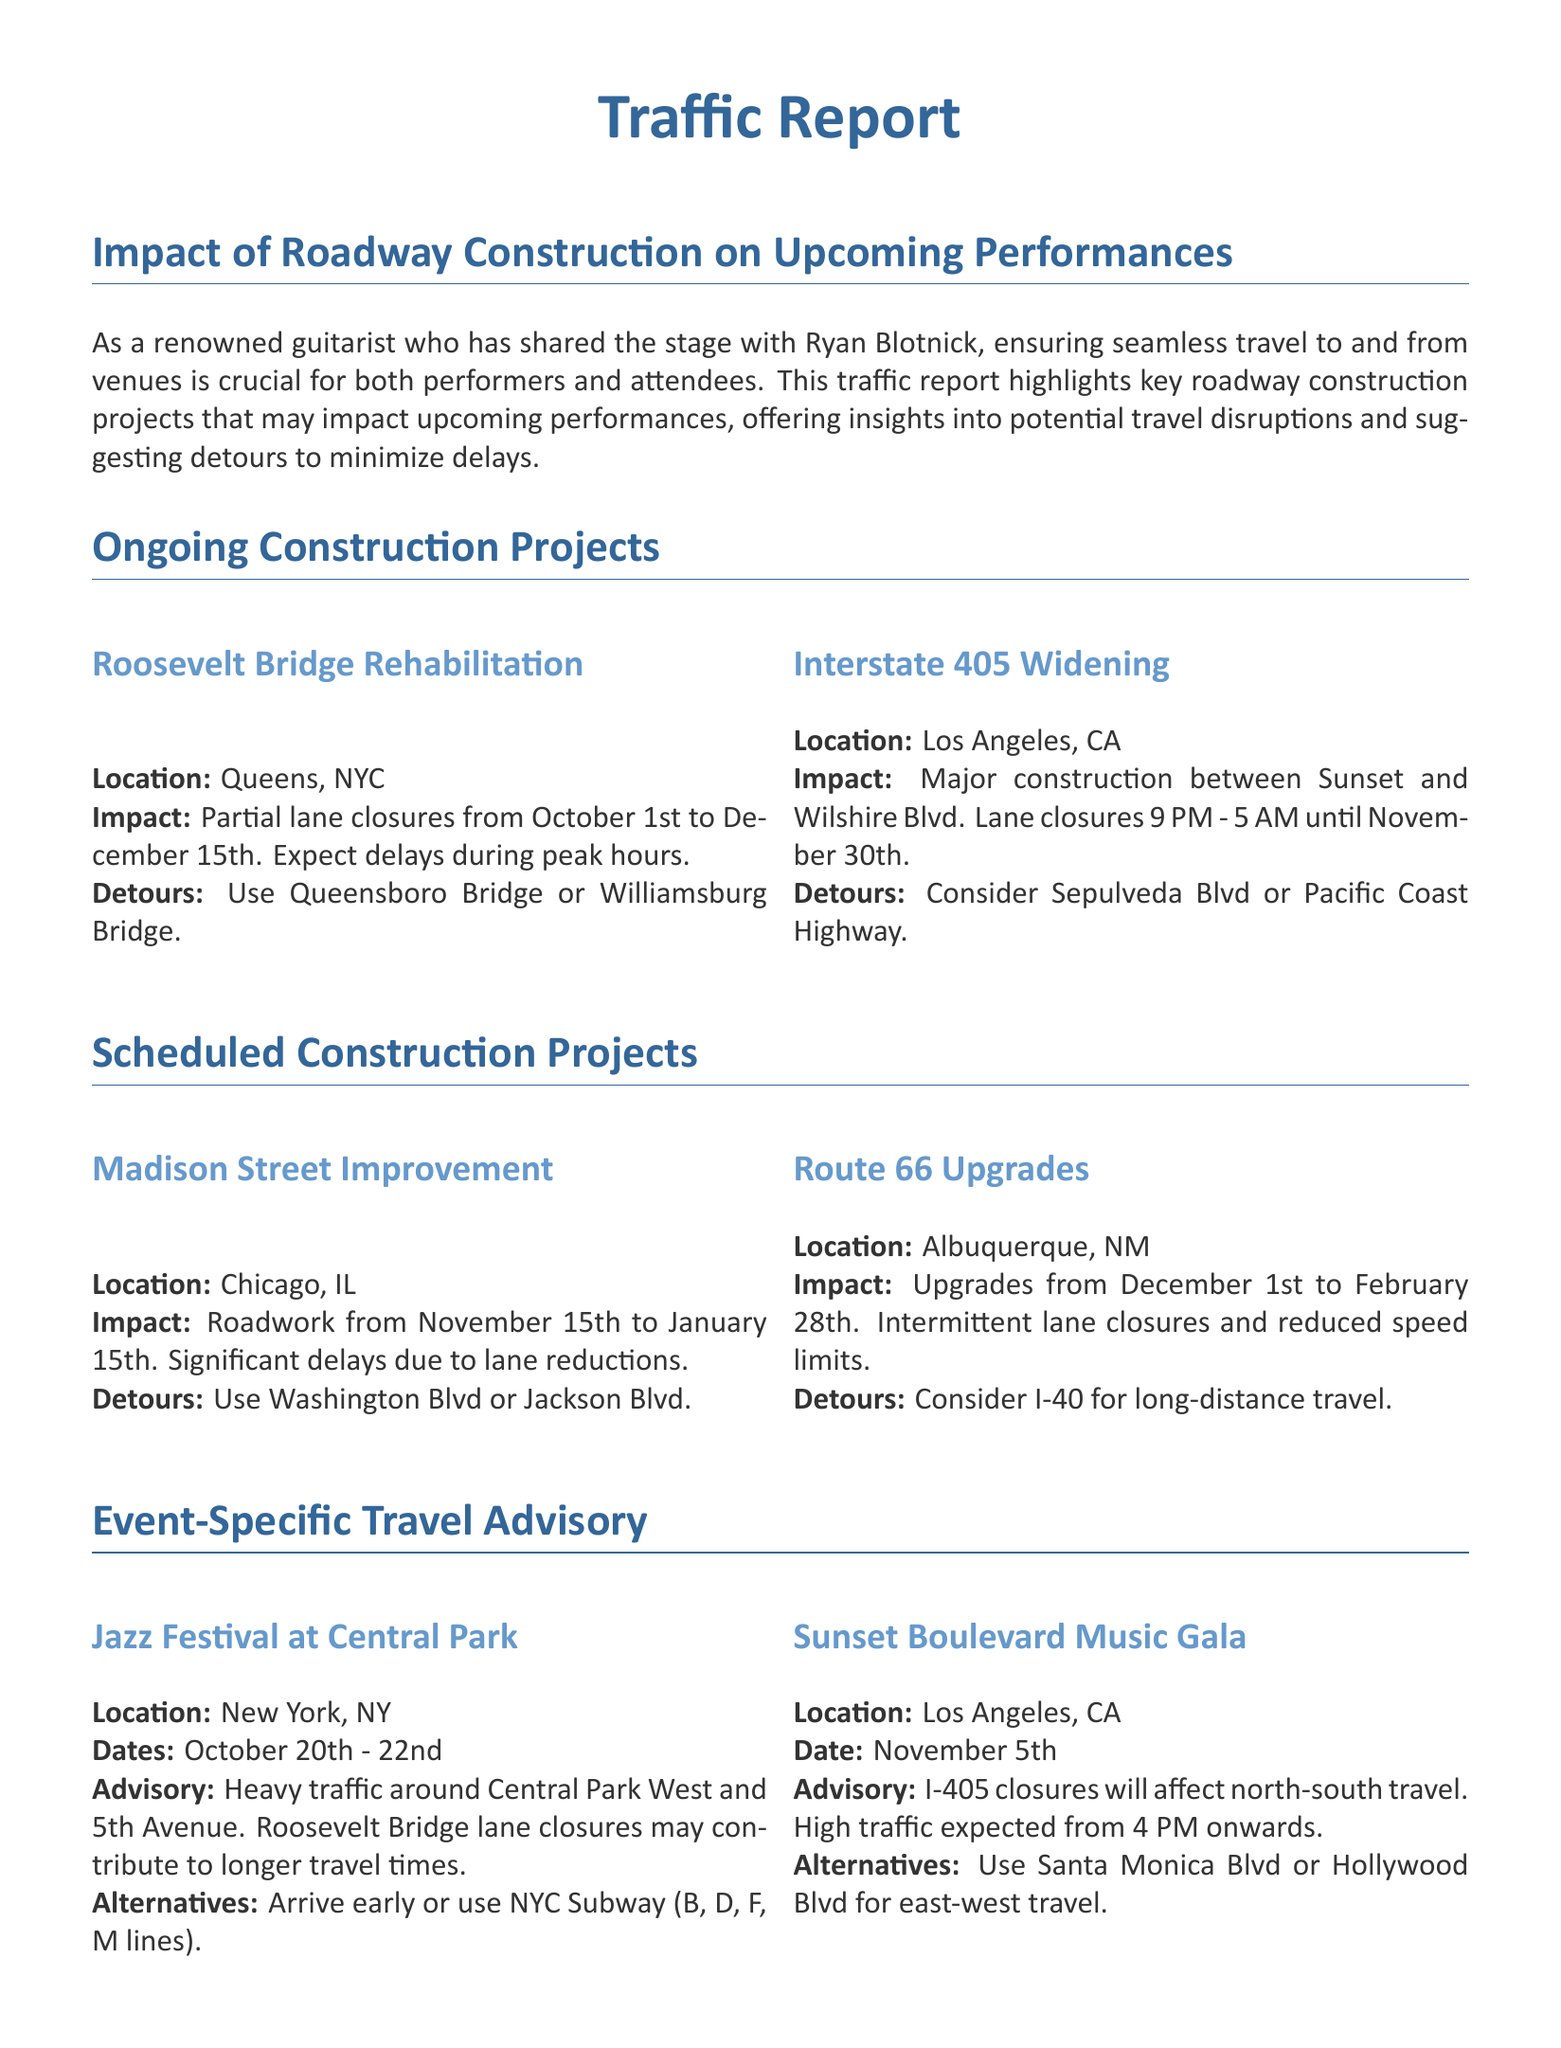What is the location of the Roosevelt Bridge Rehabilitation project? The document specifies that the Roosevelt Bridge Rehabilitation project is located in Queens, NYC.
Answer: Queens, NYC What are the dates for the Sunset Boulevard Music Gala? The document provides the date for the Sunset Boulevard Music Gala as November 5th.
Answer: November 5th What is the impact of the Interstate 405 Widening project? The document states that the impact includes major construction and lane closures from 9 PM to 5 AM until November 30th.
Answer: Major construction, lane closures 9 PM - 5 AM What are the suggested detours for the Madison Street Improvement project? The document lists Washington Blvd and Jackson Blvd as suggested detours for the Madison Street Improvement project.
Answer: Washington Blvd or Jackson Blvd How long will the roadwork for Route 66 Upgrades last? According to the document, the roadwork for Route 66 Upgrades will last from December 1st to February 28th.
Answer: December 1st to February 28th What alternatives does the report suggest for attendees traveling to the Jazz Festival at Central Park? The document advises attendees to arrive early or use the NYC Subway (B, D, F, M lines) as alternatives for the Jazz Festival.
Answer: Arrive early or use NYC Subway (B, D, F, M lines) What time frame is indicated for lane closures during the Roosevelt Bridge rehabilitation? The document notes that the lane closures for the Roosevelt Bridge rehabilitation are from October 1st to December 15th.
Answer: October 1st to December 15th What is a general travel tip provided in the report? The document includes a tip to monitor live traffic updates through local news stations or GPS apps.
Answer: Monitor live traffic updates through local news stations or GPS apps 